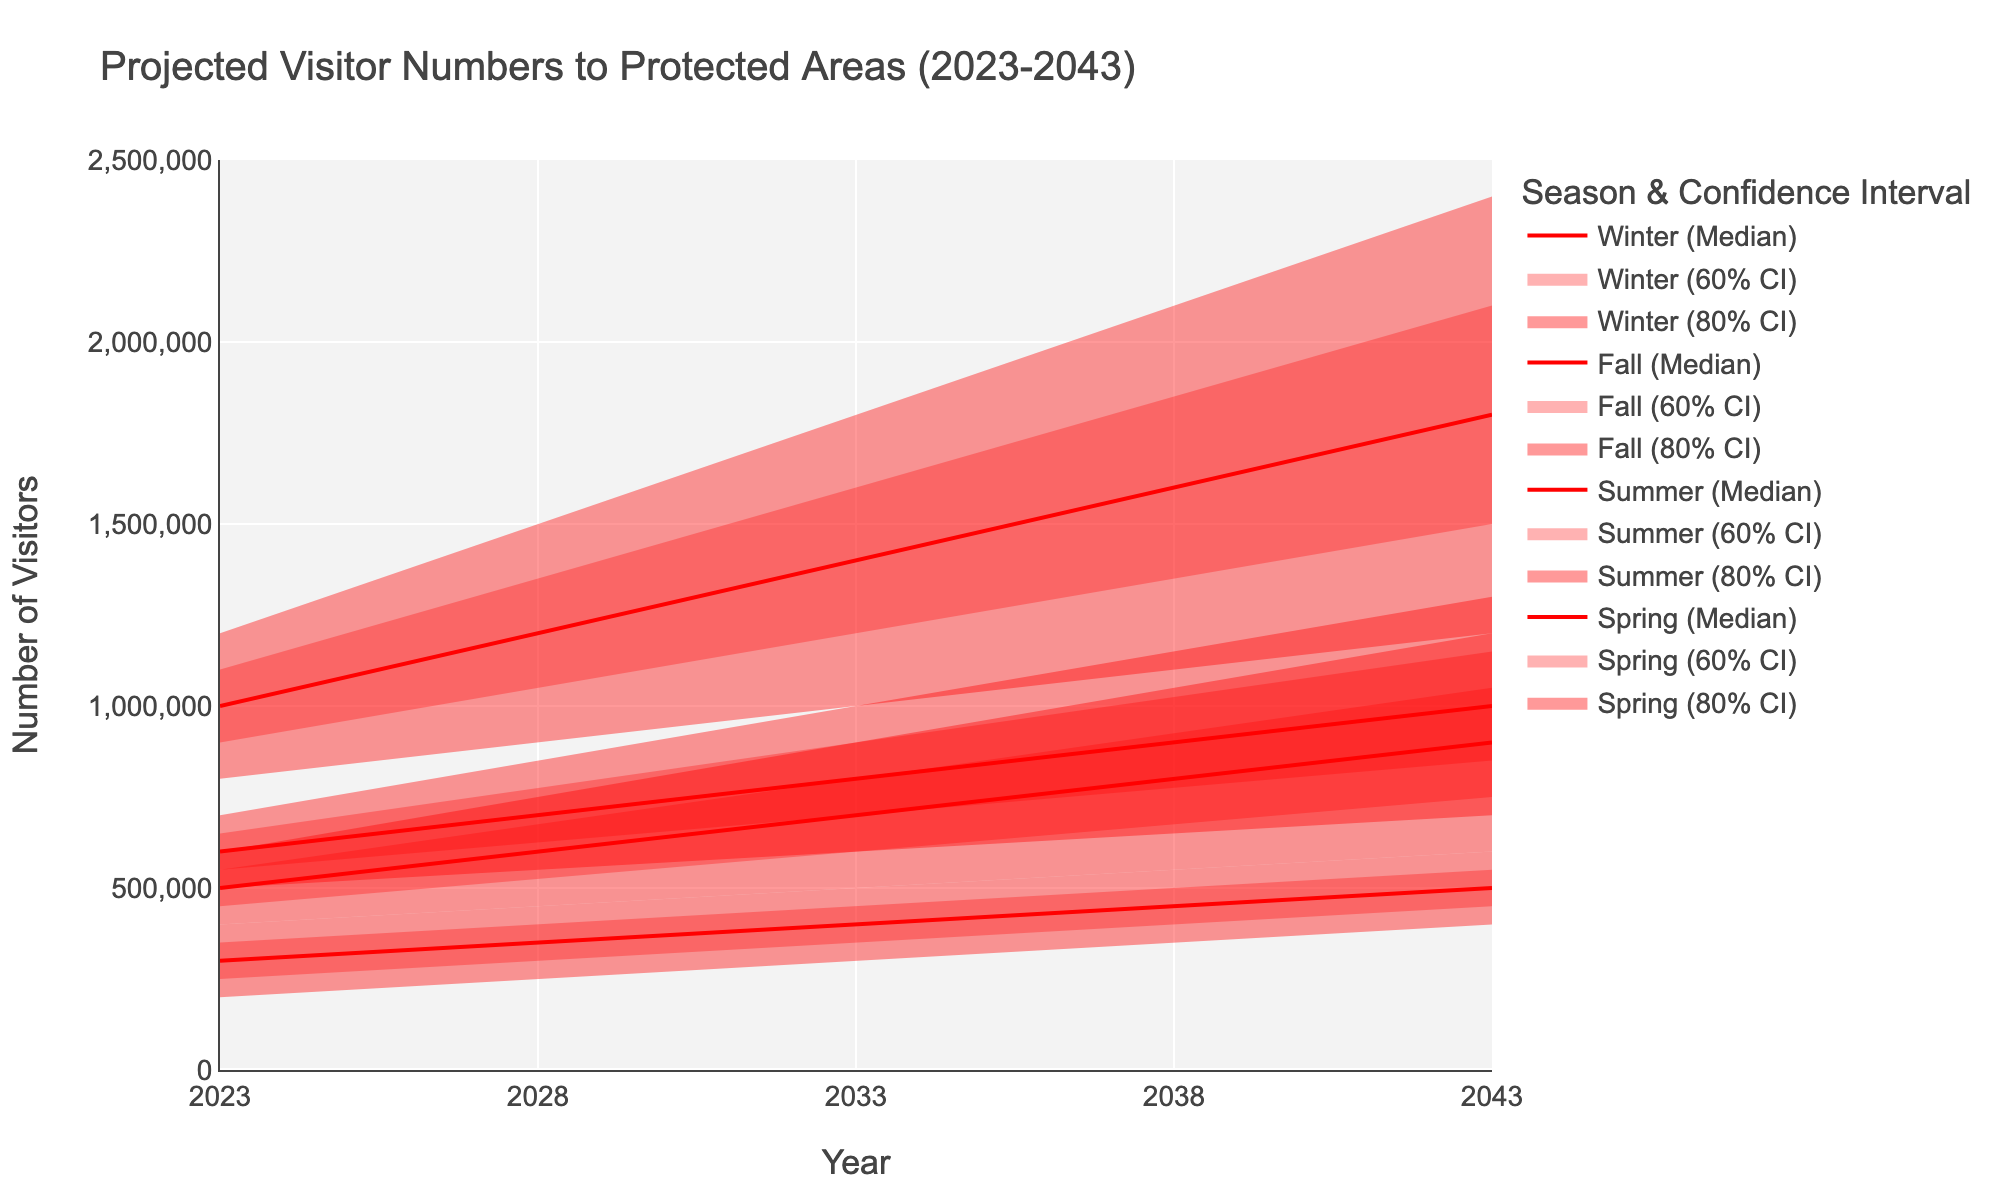What is the title of the chart? The title is usually displayed centrally at the top of the chart. According to the data and code, the title is "Projected Visitor Numbers to Protected Areas (2023-2043)".
Answer: Projected Visitor Numbers to Protected Areas (2023-2043) Which season has the highest median projected visitor numbers in 2043? Look at the median values for each season in 2043 and compare. Spring has 1,000,000; Summer has 1,800,000; Fall has 900,000; Winter has 500,000. Summer has the highest value.
Answer: Summer What is the median visitor number for Spring in the year 2028? Find the "Mid" column value for Spring in the year 2028. The value is 700,000.
Answer: 700,000 How many years are represented in the chart? Count the unique years in the data provided: 2023, 2028, 2033, 2038, and 2043. Thus, there are 5 years represented.
Answer: 5 What is the range of projected visitor numbers for Winter in 2023? The range is calculated by subtracting the lowest value (200,000) from the highest value (400,000) for Winter in 2023. The range is 400,000 - 200,000 = 200,000.
Answer: 200,000 Which season shows the least variability in visitor projections for the year 2038? Variability can be inferred from the gap between the "Low" and "High" values for each season in 2038. The differences are: Spring = 500,000, Summer = 1,000,000, Fall = 500,000, Winter = 200,000. Winter has the least variability.
Answer: Winter In which season and year can we expect the visitor numbers to first surpass 1 million at the lowest confidence interval? Look for the "Low" values that first exceed 1,000,000. For Summer in 2033, the "Low" is 1,000,000, which meets the criteria.
Answer: Summer 2033 Which season has the highest projected upper limit of visitors in 2043? Look at the "High" values for each season in 2043. Spring is 1,300,000, Summer is 2,400,000, Fall is 1,200,000, Winter is 600,000. Summer has the highest upper limit.
Answer: Summer 